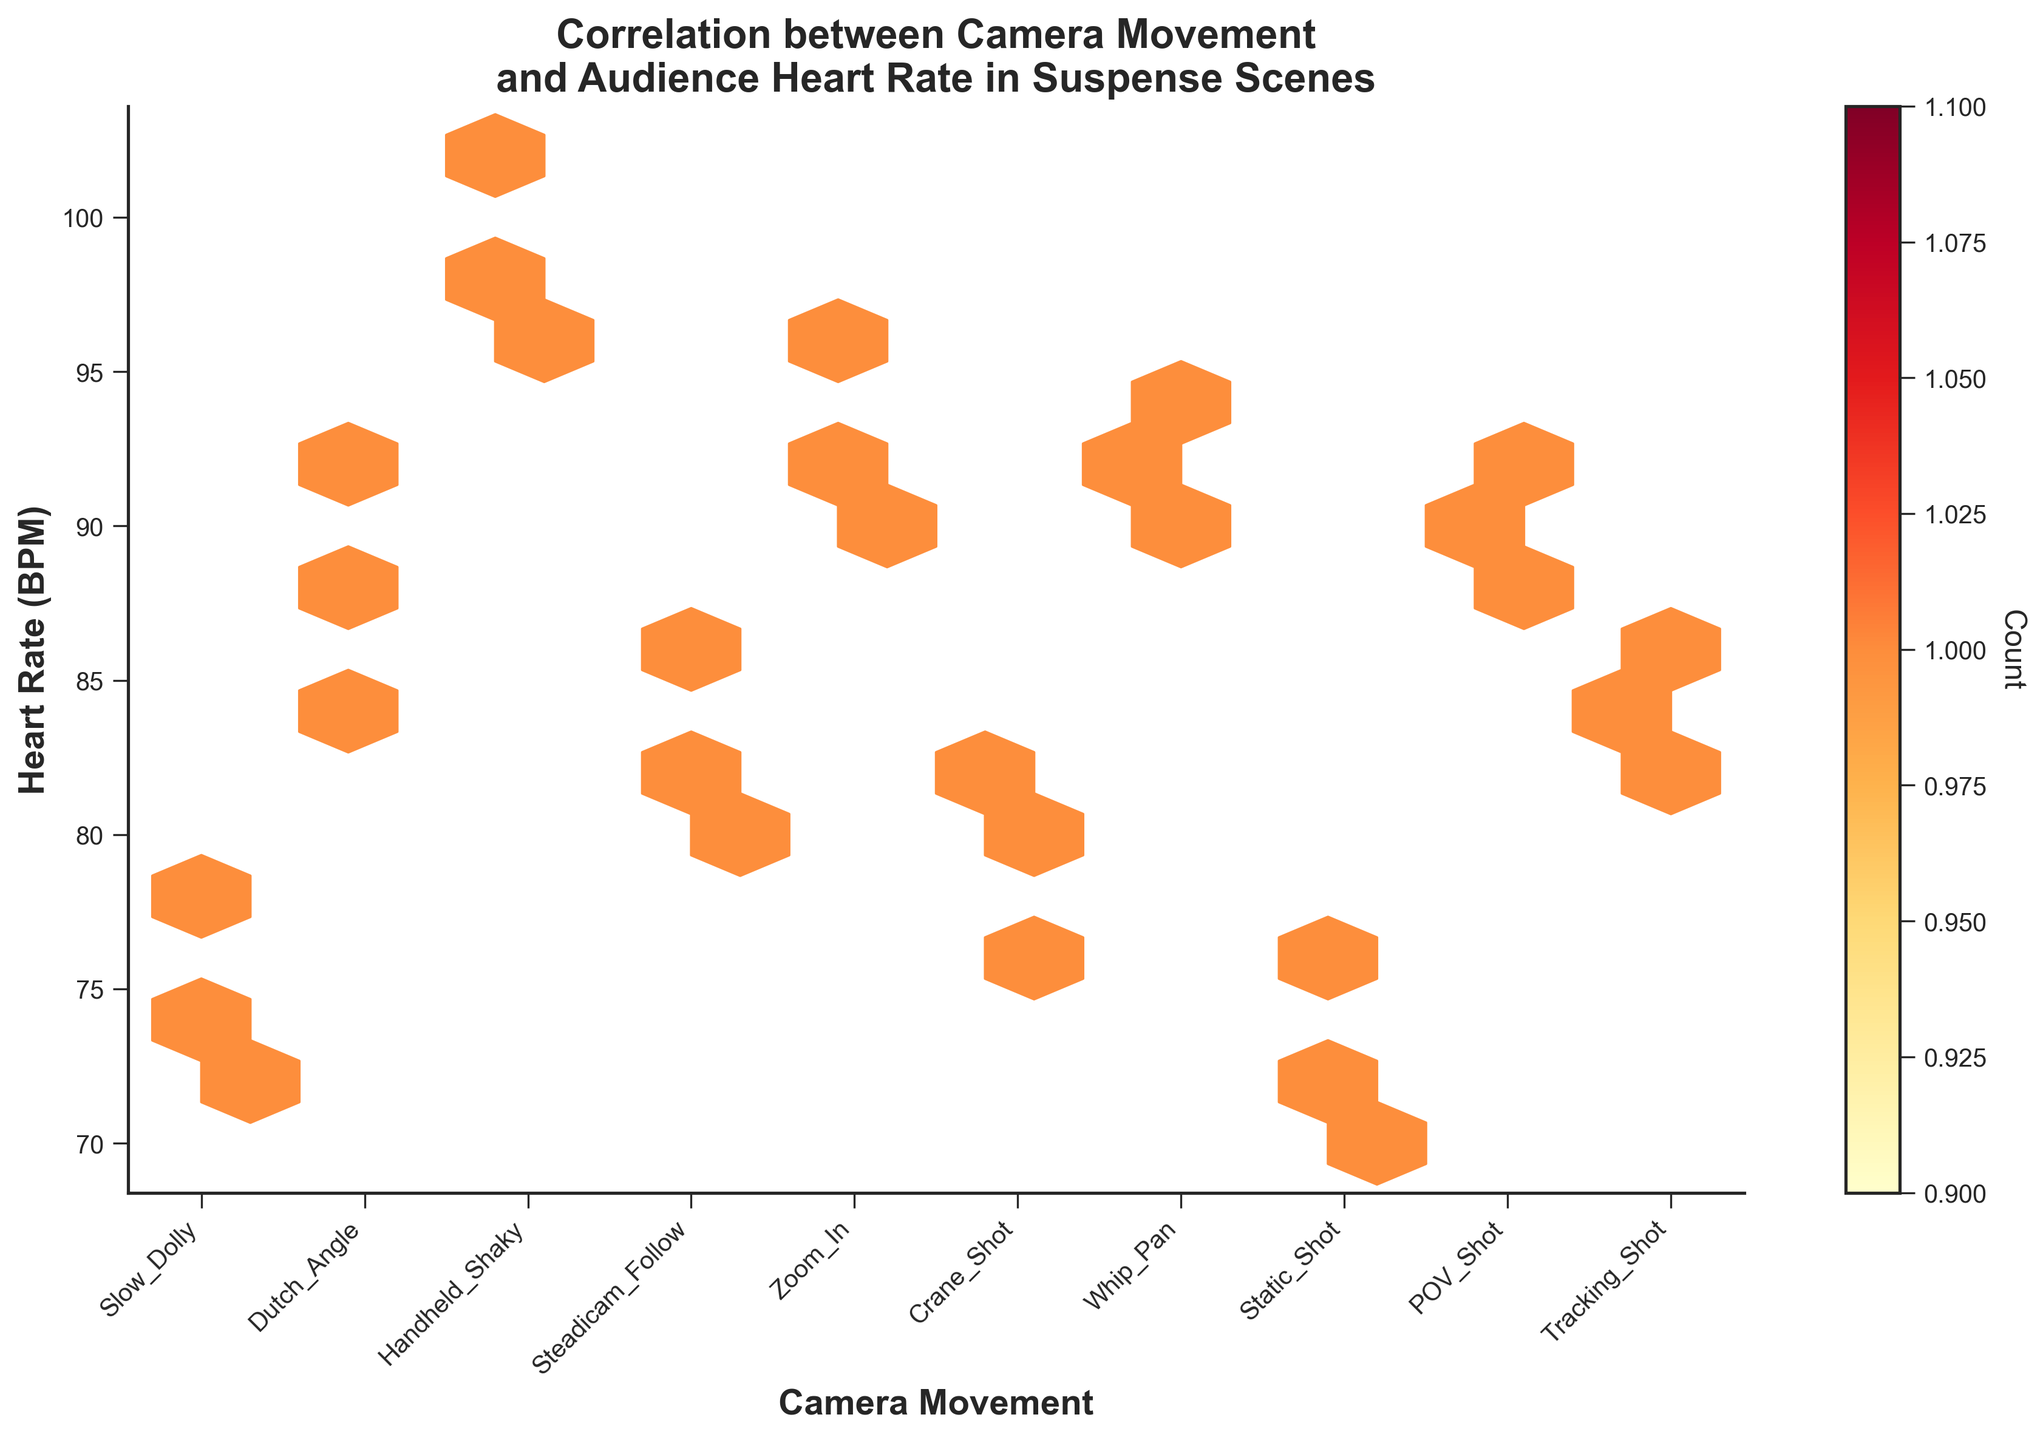What's the title of the figure? The title is usually the largest text, located at the top of the figure, summarizing its main theme. Here, it reads "Correlation between Camera Movement and Audience Heart Rate in Suspense Scenes".
Answer: Correlation between Camera Movement and Audience Heart Rate in Suspense Scenes What's the x-axis label of the figure? The x-axis label is usually found on the bottom edge of the figure, describing what the horizontal axis represents. Here, it reads "Camera Movement".
Answer: Camera Movement What camera movement has the highest heart rate recorded in the plot? Look for the highest point on the y-axis and check which x-axis category (camera movement) it aligns with. The highest heart rate recorded is 102 BPM, which corresponds to "Handheld Shaky".
Answer: Handheld Shaky Which camera movements show heart rates above 90 BPM? Observe the plot and focus on the camera movements where data points exist with y-values above 90 BPM. These are: "Dutch Angle", "Handheld Shaky", "Zoom In", "Whip Pan", and "POV Shot".
Answer: Dutch Angle, Handheld Shaky, Zoom In, Whip Pan, POV Shot What's the average heart rate for the 'Slow Dolly' camera movement? Identify all heart rate data points corresponding to "Slow Dolly": 72, 75, and 78. Calculate the average: (72 + 75 + 78) / 3 = 225 / 3 = 75 BPM.
Answer: 75 BPM Which camera movement shows the lowest recorded heart rate? Locate the lowest point on the y-axis and check which camera movement it aligns with. The lowest heart rate recorded is 70 BPM, corresponding to "Static Shot".
Answer: Static Shot Compare the heart rate ranges for "Handheld Shaky" and "Steadicam Follow". Which has a wider range? Determine the range by subtracting the lowest heart rate from the highest for each camera movement. "Handheld Shaky": 102 - 95 = 7 BPM. "Steadicam Follow": 86 - 80 = 6 BPM. "Handheld Shaky" has a wider range.
Answer: Handheld Shaky What is the color of the hexbins where most data points for 'Zoom In' are located? Identify the hexagons for "Zoom In" and observe their colors. They are in the 'YlOrRd' (Yellow-Orange-Red) gradient, likely appearing orange to red where more data points gather.
Answer: Orange to Red Which camera movement shows the most uniform heart rates around the mean? Identify the camera movement where data points cluster closely around a central value. "Static Shot" shows uniform heart rates around the mean of 73 BPM, as the points are close together without wide variance.
Answer: Static Shot 